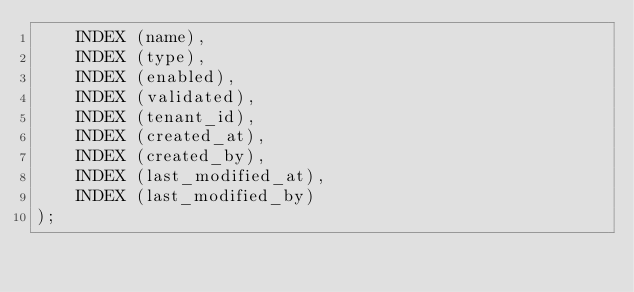Convert code to text. <code><loc_0><loc_0><loc_500><loc_500><_SQL_>    INDEX (name),
    INDEX (type),
    INDEX (enabled),
    INDEX (validated),
    INDEX (tenant_id),
    INDEX (created_at),
    INDEX (created_by),
    INDEX (last_modified_at),
    INDEX (last_modified_by)
);
</code> 